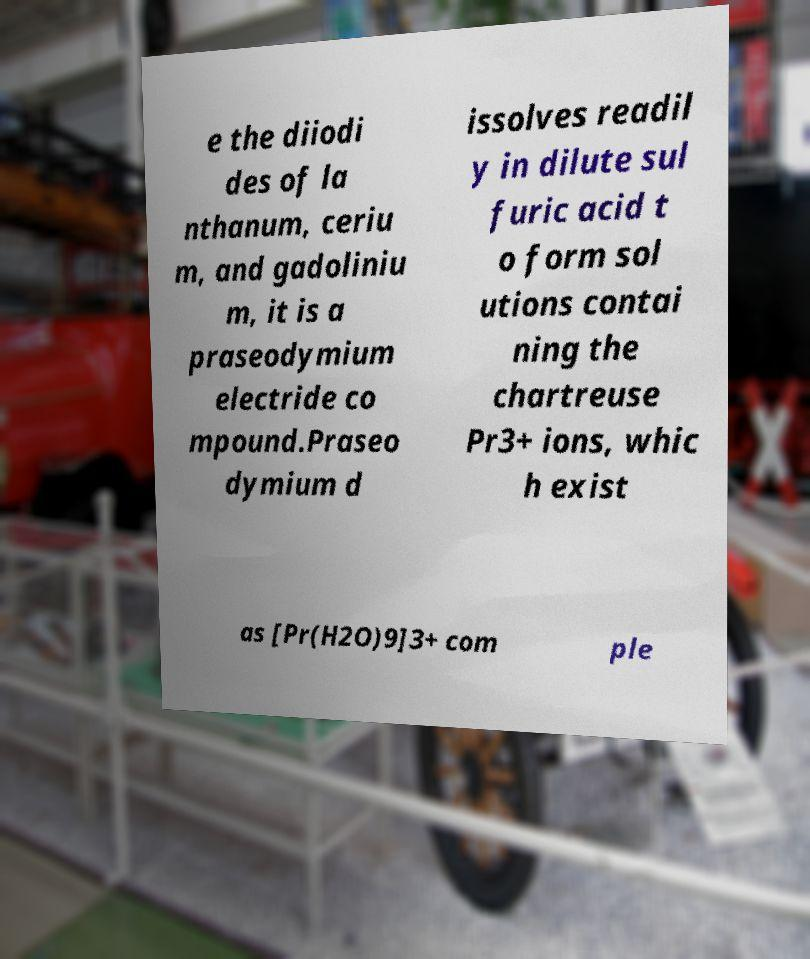Can you accurately transcribe the text from the provided image for me? e the diiodi des of la nthanum, ceriu m, and gadoliniu m, it is a praseodymium electride co mpound.Praseo dymium d issolves readil y in dilute sul furic acid t o form sol utions contai ning the chartreuse Pr3+ ions, whic h exist as [Pr(H2O)9]3+ com ple 